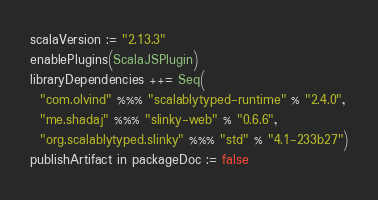Convert code to text. <code><loc_0><loc_0><loc_500><loc_500><_Scala_>scalaVersion := "2.13.3"
enablePlugins(ScalaJSPlugin)
libraryDependencies ++= Seq(
  "com.olvind" %%% "scalablytyped-runtime" % "2.4.0",
  "me.shadaj" %%% "slinky-web" % "0.6.6",
  "org.scalablytyped.slinky" %%% "std" % "4.1-233b27")
publishArtifact in packageDoc := false</code> 